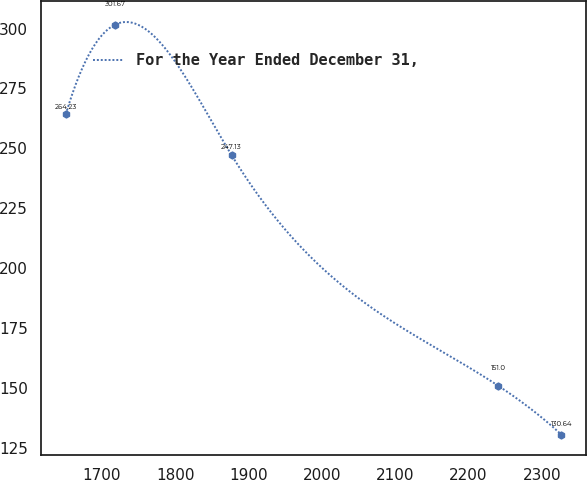Convert chart to OTSL. <chart><loc_0><loc_0><loc_500><loc_500><line_chart><ecel><fcel>For the Year Ended December 31,<nl><fcel>1651.1<fcel>264.23<nl><fcel>1718.62<fcel>301.67<nl><fcel>1877.13<fcel>247.13<nl><fcel>2240.29<fcel>151<nl><fcel>2326.33<fcel>130.64<nl></chart> 